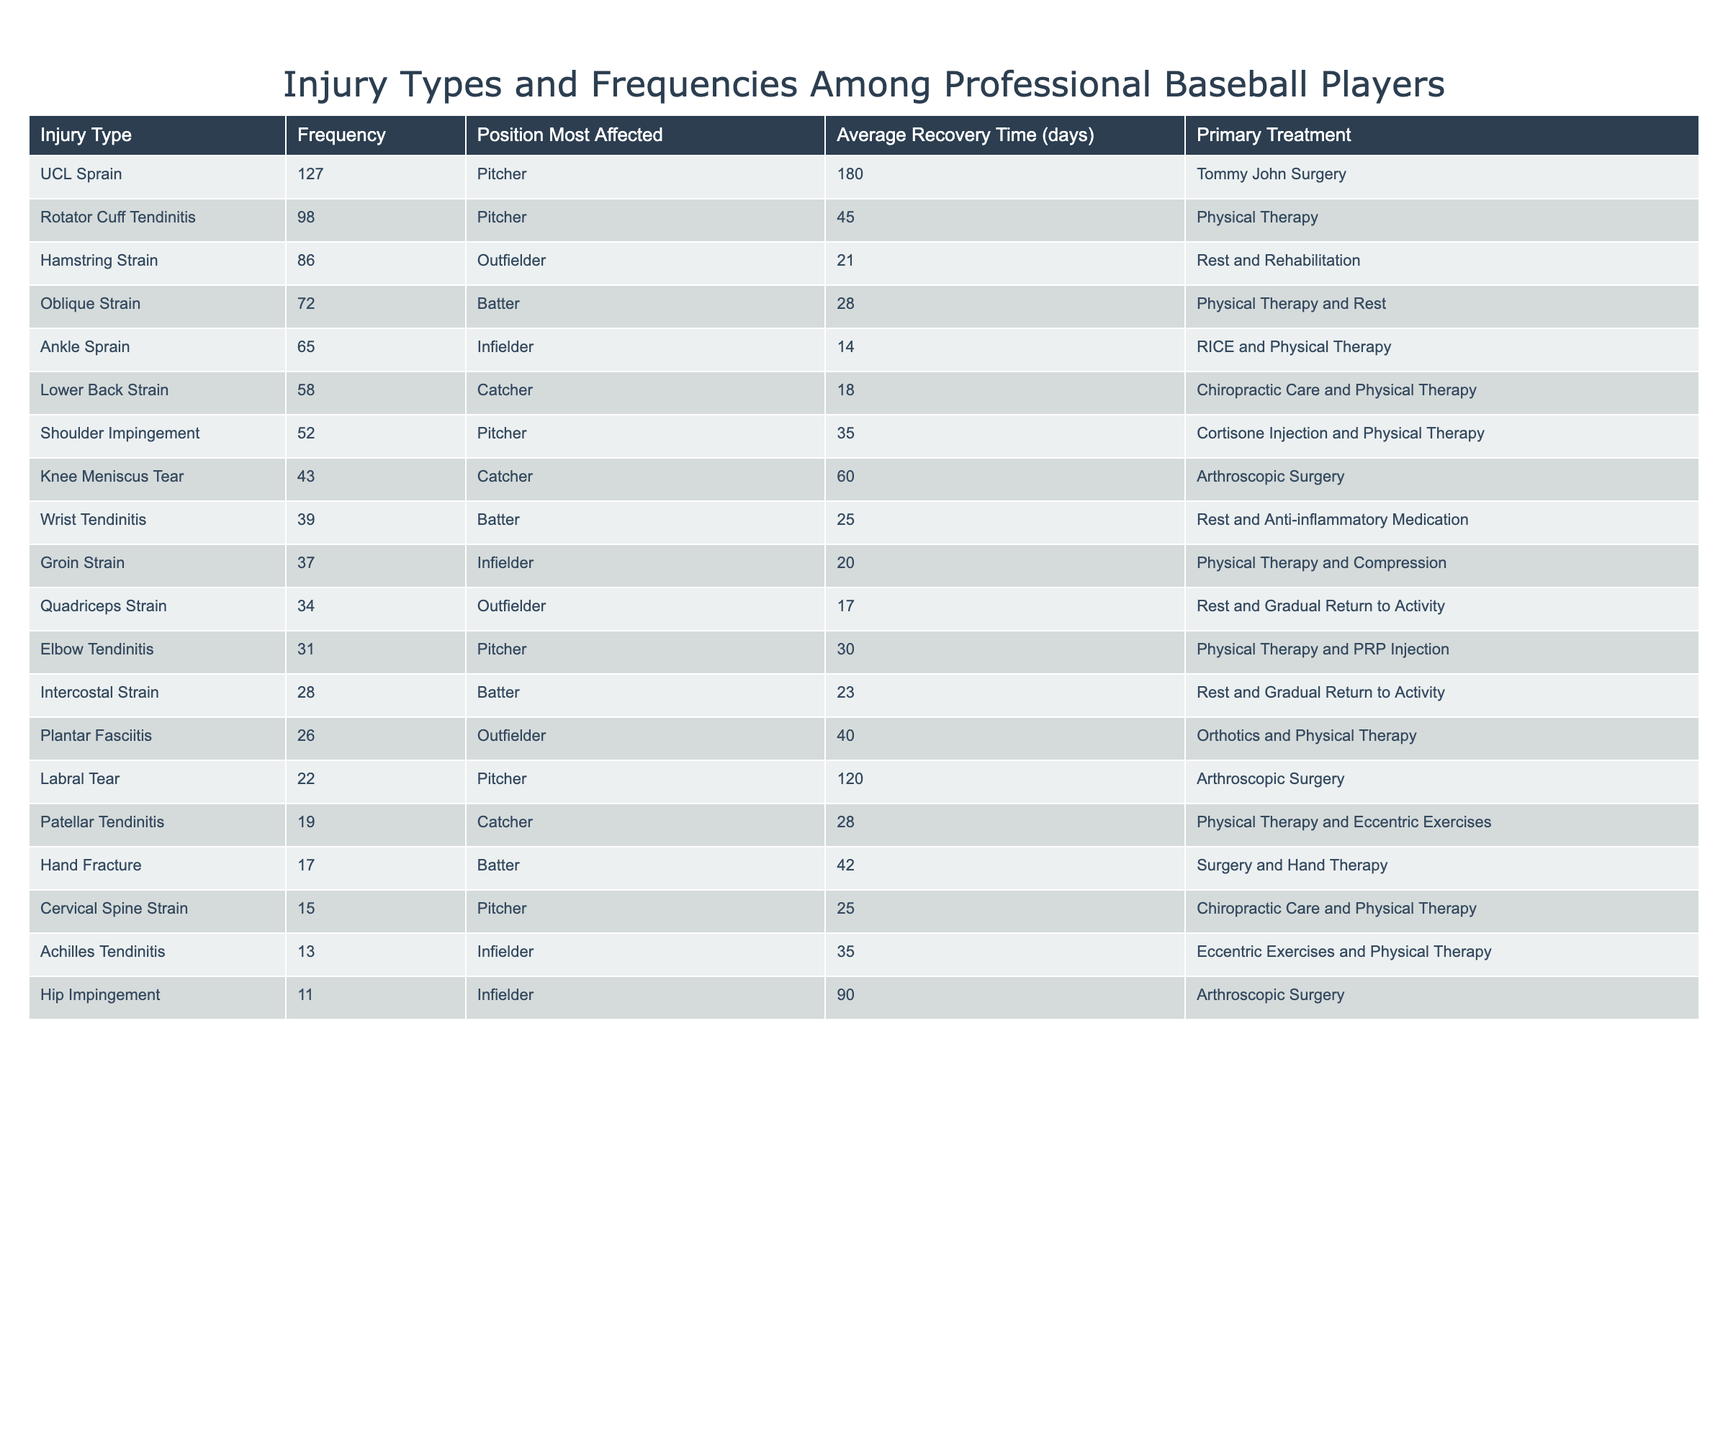What is the most common injury type among professional baseball players? By looking at the "Frequency" column, we can identify that "UCL Sprain" has the highest frequency of 127.
Answer: UCL Sprain How many injuries are classified under the category of "Strain"? We can count the instances of "Strain" in the "Injury Type" column: Hamstring Strain, Lower Back Strain, Groin Strain, Quadriceps Strain, and Cervical Spine Strain (5 injuries).
Answer: 5 What is the average recovery time for all injuries listed in the table? To find the average recovery time, we sum up the total recovery times: (180 + 45 + 21 + 28 + 14 + 18 + 35 + 60 + 25 + 20 + 17 + 30 + 23 + 40 + 120 + 28 + 42 + 25 + 35 + 90) = 670. There are 20 data points, thus the average is 670/20 = 33.5 days.
Answer: 33.5 days Is "Rotator Cuff Tendinitis" treated primarily with surgery? The table shows that Rotator Cuff Tendinitis is treated with Physical Therapy, not surgery, so the answer is no.
Answer: No How many pitchers are affected by injuries that require surgical intervention? We find the injuries for pitchers needing surgery: UCL Sprain (Tommy John Surgery), Labral Tear (Arthroscopic Surgery), and others that involve surgical intervention can be filtered. Thus, the count is 3: UCL Sprain, Labral Tear, and knee-related surgery.
Answer: 3 What is the frequency of elbow tendinitis in comparison to hamstring strains? The frequency for elbow tendinitis is 31, while hamstring strains have a frequency of 86. Comparing these, we see that hamstring strains are more frequent. Specifically, 86 - 31 = 55.
Answer: Hamstring strains are more frequent by 55 What is the most prevalent injury among outfielders based on the data? Checking the frequencies for outfielder injuries: Hamstring Strain (86), Quadriceps Strain (34), and Plantar Fasciitis (26). The highest is 86, which corresponds to the Hamstring Strain.
Answer: Hamstring Strain How long does it take on average to recover from injuries treated with Physical Therapy alone? The injuries treated with Physical Therapy are: Rotator Cuff Tendinitis (45), Oblique Strain (28), Shoulder Impingement (35), Elbow Tendinitis (30), Patellar Tendinitis (28), and Achilles Tendinitis (35). Summing these recovery times: (45 + 28 + 35 + 30 + 28 + 35) = 201 days. The average is 201/6 = 33.5.
Answer: 33.5 days Are knee meniscus tears more frequent than ankle sprains? The frequency for knee meniscus tears is 43, while for ankle sprains it is 65. Since 43 is less than 65, the answer is no.
Answer: No What percentage of total injuries do UCL Sprains represent? The total frequency of all injuries is 670. UCL Sprains account for 127 of those. The percentage is calculated as (127/670) * 100 ≈ 18.9%.
Answer: Approximately 18.9% Which injury type has the longest average recovery time and what is it? Observing the average recovery times, UCL Sprain has 180 days. Comparing others shows that it is the longest, as the next highest is 120 (Labral Tear).
Answer: UCL Sprain, 180 days 